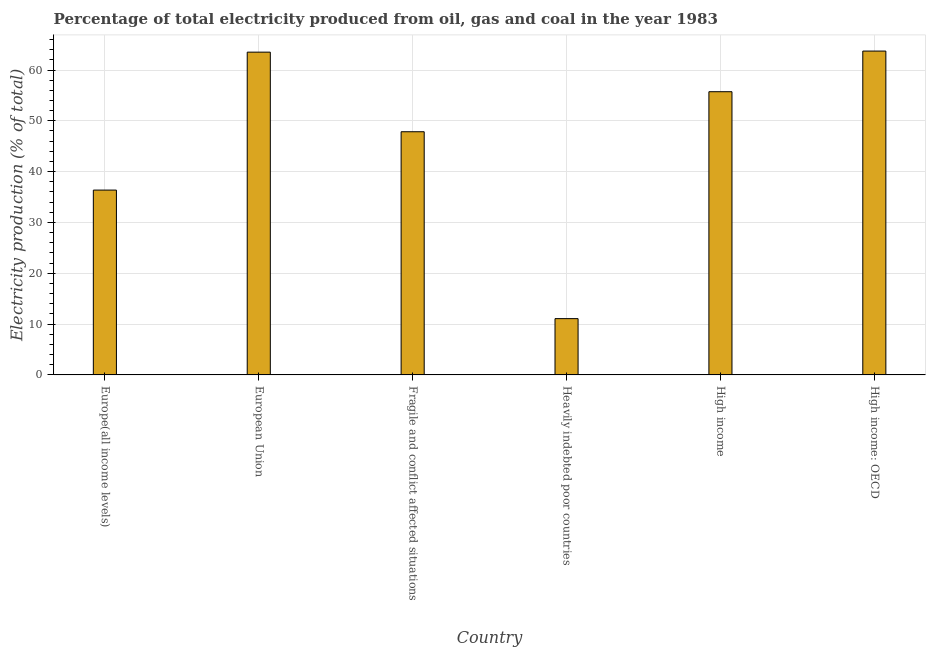Does the graph contain grids?
Offer a very short reply. Yes. What is the title of the graph?
Your answer should be compact. Percentage of total electricity produced from oil, gas and coal in the year 1983. What is the label or title of the Y-axis?
Make the answer very short. Electricity production (% of total). What is the electricity production in Fragile and conflict affected situations?
Offer a terse response. 47.85. Across all countries, what is the maximum electricity production?
Offer a very short reply. 63.73. Across all countries, what is the minimum electricity production?
Your answer should be very brief. 11.07. In which country was the electricity production maximum?
Keep it short and to the point. High income: OECD. In which country was the electricity production minimum?
Provide a succinct answer. Heavily indebted poor countries. What is the sum of the electricity production?
Provide a succinct answer. 278.27. What is the difference between the electricity production in Fragile and conflict affected situations and High income?
Provide a succinct answer. -7.88. What is the average electricity production per country?
Make the answer very short. 46.38. What is the median electricity production?
Your response must be concise. 51.79. In how many countries, is the electricity production greater than 10 %?
Your response must be concise. 6. What is the ratio of the electricity production in European Union to that in Heavily indebted poor countries?
Provide a succinct answer. 5.74. Is the electricity production in Europe(all income levels) less than that in Heavily indebted poor countries?
Your response must be concise. No. What is the difference between the highest and the second highest electricity production?
Your answer should be very brief. 0.21. What is the difference between the highest and the lowest electricity production?
Make the answer very short. 52.65. Are all the bars in the graph horizontal?
Ensure brevity in your answer.  No. How many countries are there in the graph?
Keep it short and to the point. 6. What is the Electricity production (% of total) of Europe(all income levels)?
Offer a terse response. 36.37. What is the Electricity production (% of total) of European Union?
Your response must be concise. 63.52. What is the Electricity production (% of total) in Fragile and conflict affected situations?
Ensure brevity in your answer.  47.85. What is the Electricity production (% of total) of Heavily indebted poor countries?
Your response must be concise. 11.07. What is the Electricity production (% of total) of High income?
Your response must be concise. 55.73. What is the Electricity production (% of total) in High income: OECD?
Offer a very short reply. 63.73. What is the difference between the Electricity production (% of total) in Europe(all income levels) and European Union?
Provide a short and direct response. -27.15. What is the difference between the Electricity production (% of total) in Europe(all income levels) and Fragile and conflict affected situations?
Ensure brevity in your answer.  -11.48. What is the difference between the Electricity production (% of total) in Europe(all income levels) and Heavily indebted poor countries?
Keep it short and to the point. 25.3. What is the difference between the Electricity production (% of total) in Europe(all income levels) and High income?
Ensure brevity in your answer.  -19.36. What is the difference between the Electricity production (% of total) in Europe(all income levels) and High income: OECD?
Provide a succinct answer. -27.36. What is the difference between the Electricity production (% of total) in European Union and Fragile and conflict affected situations?
Ensure brevity in your answer.  15.67. What is the difference between the Electricity production (% of total) in European Union and Heavily indebted poor countries?
Your answer should be very brief. 52.44. What is the difference between the Electricity production (% of total) in European Union and High income?
Your answer should be very brief. 7.79. What is the difference between the Electricity production (% of total) in European Union and High income: OECD?
Ensure brevity in your answer.  -0.21. What is the difference between the Electricity production (% of total) in Fragile and conflict affected situations and Heavily indebted poor countries?
Provide a short and direct response. 36.78. What is the difference between the Electricity production (% of total) in Fragile and conflict affected situations and High income?
Offer a very short reply. -7.88. What is the difference between the Electricity production (% of total) in Fragile and conflict affected situations and High income: OECD?
Offer a very short reply. -15.88. What is the difference between the Electricity production (% of total) in Heavily indebted poor countries and High income?
Give a very brief answer. -44.65. What is the difference between the Electricity production (% of total) in Heavily indebted poor countries and High income: OECD?
Provide a succinct answer. -52.65. What is the difference between the Electricity production (% of total) in High income and High income: OECD?
Offer a very short reply. -8. What is the ratio of the Electricity production (% of total) in Europe(all income levels) to that in European Union?
Keep it short and to the point. 0.57. What is the ratio of the Electricity production (% of total) in Europe(all income levels) to that in Fragile and conflict affected situations?
Your answer should be compact. 0.76. What is the ratio of the Electricity production (% of total) in Europe(all income levels) to that in Heavily indebted poor countries?
Ensure brevity in your answer.  3.28. What is the ratio of the Electricity production (% of total) in Europe(all income levels) to that in High income?
Provide a succinct answer. 0.65. What is the ratio of the Electricity production (% of total) in Europe(all income levels) to that in High income: OECD?
Keep it short and to the point. 0.57. What is the ratio of the Electricity production (% of total) in European Union to that in Fragile and conflict affected situations?
Provide a short and direct response. 1.33. What is the ratio of the Electricity production (% of total) in European Union to that in Heavily indebted poor countries?
Provide a succinct answer. 5.74. What is the ratio of the Electricity production (% of total) in European Union to that in High income?
Your response must be concise. 1.14. What is the ratio of the Electricity production (% of total) in Fragile and conflict affected situations to that in Heavily indebted poor countries?
Your answer should be compact. 4.32. What is the ratio of the Electricity production (% of total) in Fragile and conflict affected situations to that in High income?
Provide a short and direct response. 0.86. What is the ratio of the Electricity production (% of total) in Fragile and conflict affected situations to that in High income: OECD?
Offer a very short reply. 0.75. What is the ratio of the Electricity production (% of total) in Heavily indebted poor countries to that in High income?
Give a very brief answer. 0.2. What is the ratio of the Electricity production (% of total) in Heavily indebted poor countries to that in High income: OECD?
Ensure brevity in your answer.  0.17. What is the ratio of the Electricity production (% of total) in High income to that in High income: OECD?
Offer a very short reply. 0.87. 